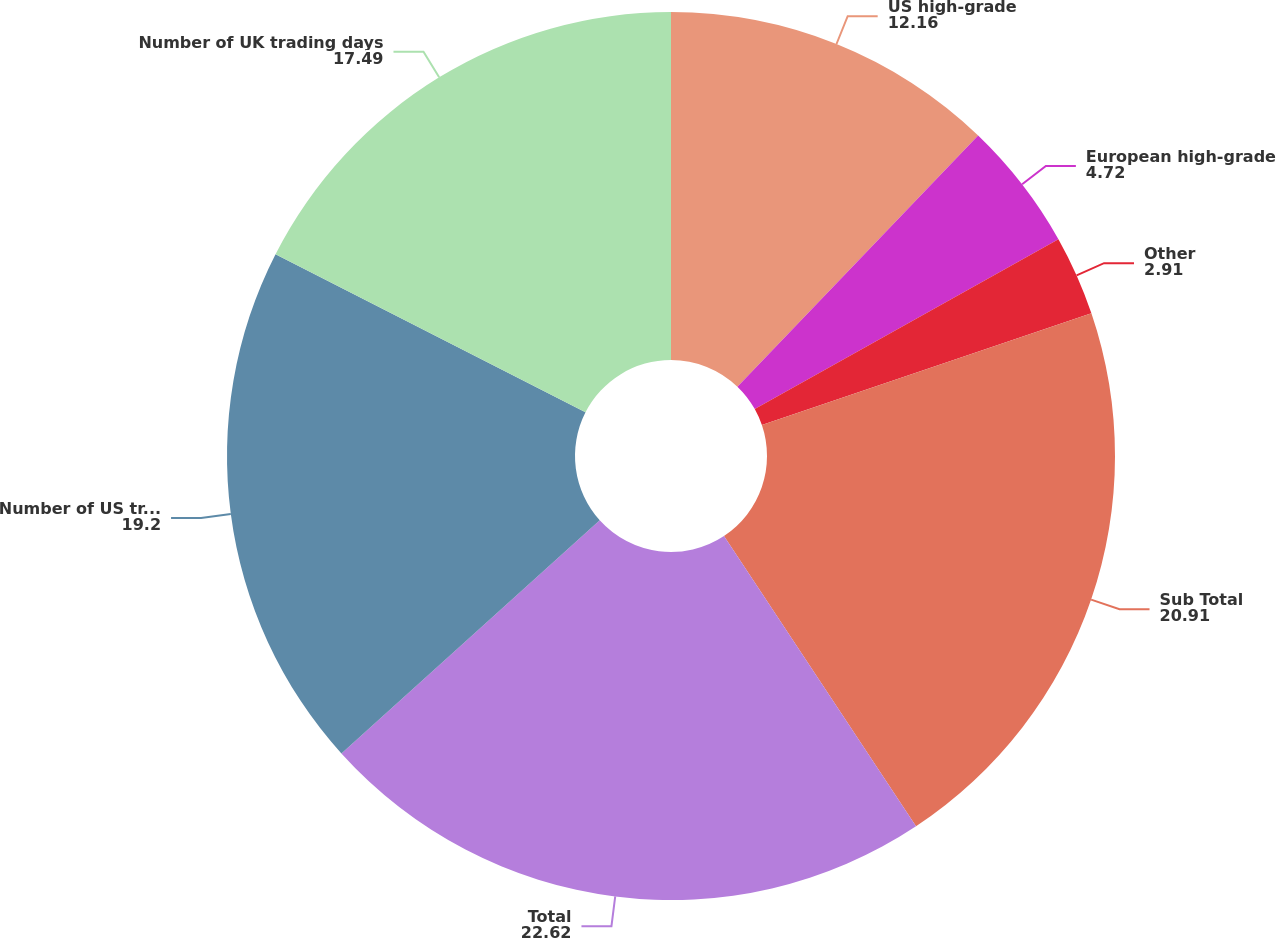Convert chart to OTSL. <chart><loc_0><loc_0><loc_500><loc_500><pie_chart><fcel>US high-grade<fcel>European high-grade<fcel>Other<fcel>Sub Total<fcel>Total<fcel>Number of US trading days<fcel>Number of UK trading days<nl><fcel>12.16%<fcel>4.72%<fcel>2.91%<fcel>20.91%<fcel>22.62%<fcel>19.2%<fcel>17.49%<nl></chart> 